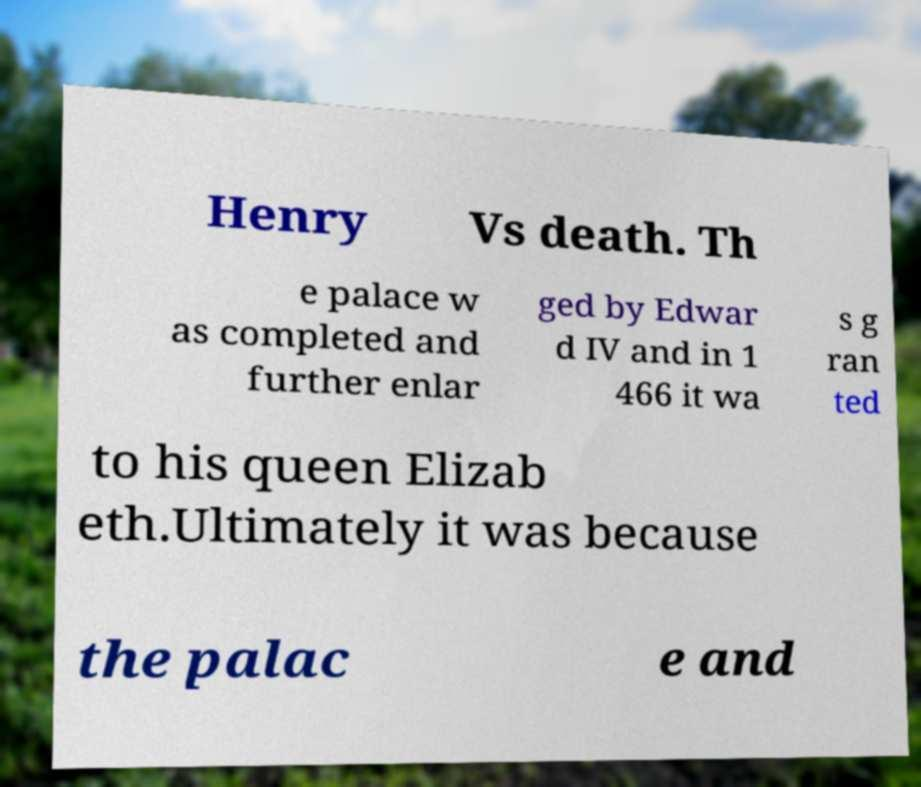Can you read and provide the text displayed in the image?This photo seems to have some interesting text. Can you extract and type it out for me? Henry Vs death. Th e palace w as completed and further enlar ged by Edwar d IV and in 1 466 it wa s g ran ted to his queen Elizab eth.Ultimately it was because the palac e and 